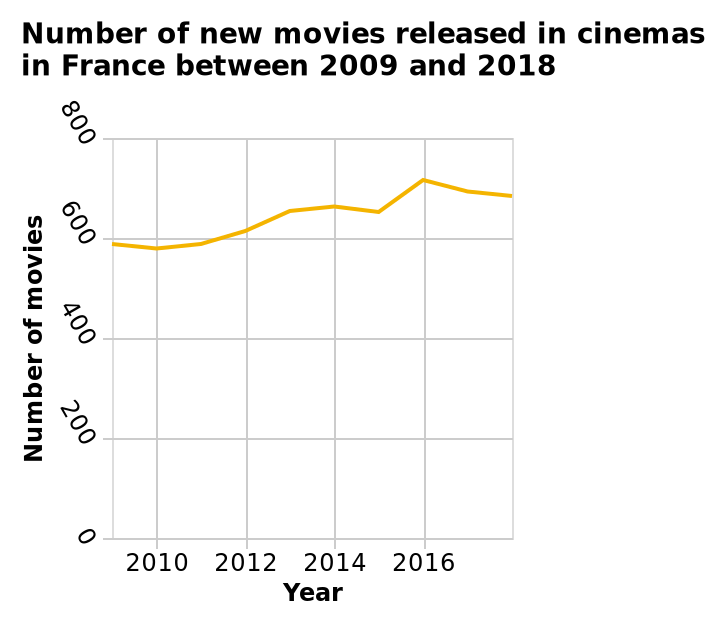<image>
Did the number of movies reach a constant level after 2016? Yes, the number of movies almost plateaued after 2016. please summary the statistics and relations of the chart Number of movies show an increase year or year, until 2016 when it drops. please describe the details of the chart Number of new movies released in cinemas in France between 2009 and 2018 is a line graph. The y-axis shows Number of movies while the x-axis shows Year. Is the number of new movies released in cinemas in France between 2009 and 2018 represented by a bar graph? Does the y-axis show the number of actors while the x-axis shows the budget? No.Number of new movies released in cinemas in France between 2009 and 2018 is a line graph. The y-axis shows Number of movies while the x-axis shows Year. 